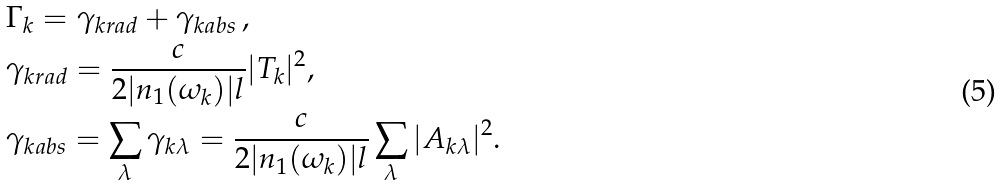Convert formula to latex. <formula><loc_0><loc_0><loc_500><loc_500>& \Gamma _ { k } = \gamma _ { k r a d } + \gamma _ { k a b s } \, , \\ & \gamma _ { k r a d } = \frac { c } { 2 | n _ { 1 } ( \omega _ { k } ) | l } | T _ { k } | ^ { 2 } , \\ & \gamma _ { k a b s } = \sum _ { \lambda } \gamma _ { k \lambda } = \frac { c } { 2 | n _ { 1 } ( \omega _ { k } ) | l } \sum _ { \lambda } | A _ { k \lambda } | ^ { 2 } .</formula> 